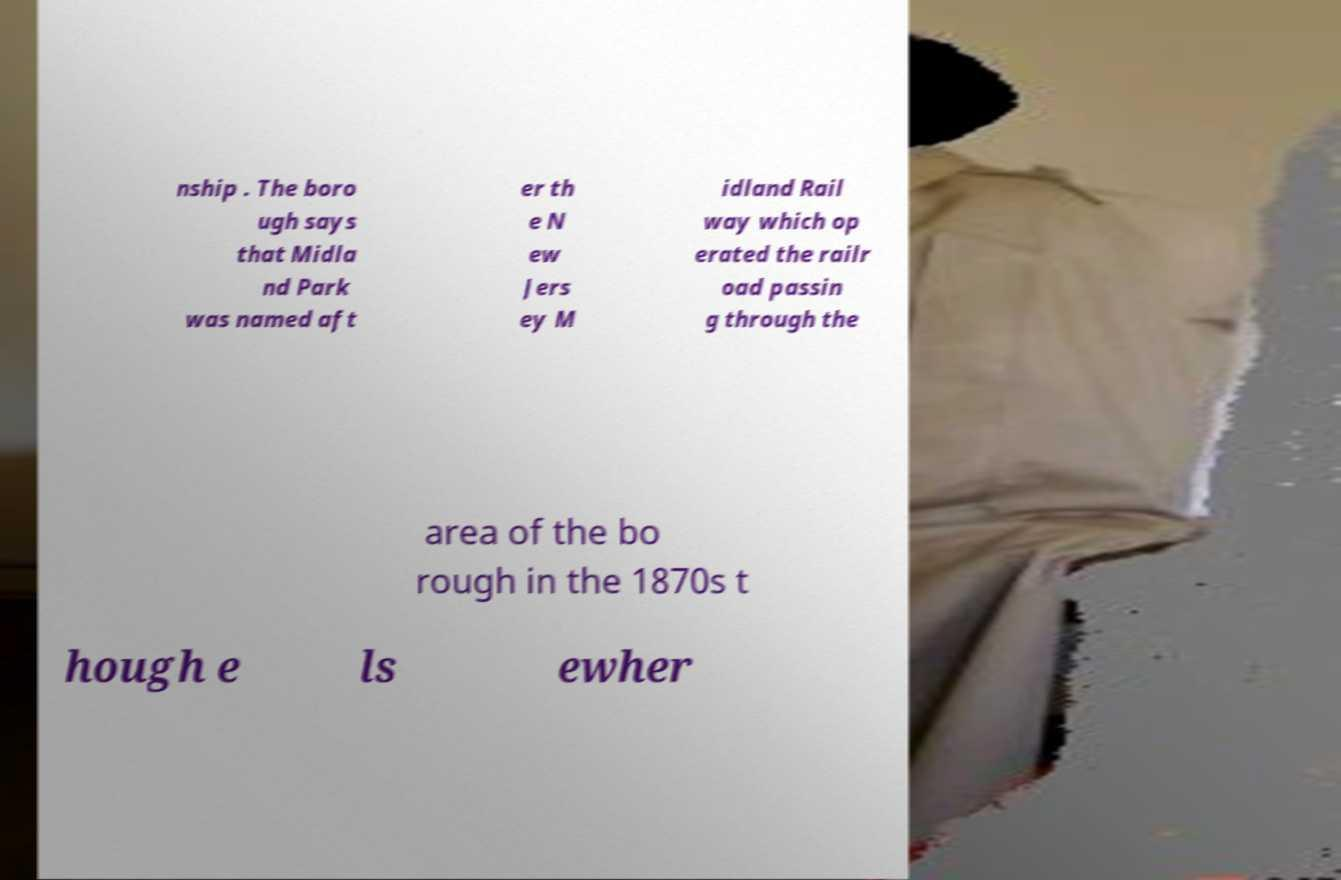For documentation purposes, I need the text within this image transcribed. Could you provide that? nship . The boro ugh says that Midla nd Park was named aft er th e N ew Jers ey M idland Rail way which op erated the railr oad passin g through the area of the bo rough in the 1870s t hough e ls ewher 